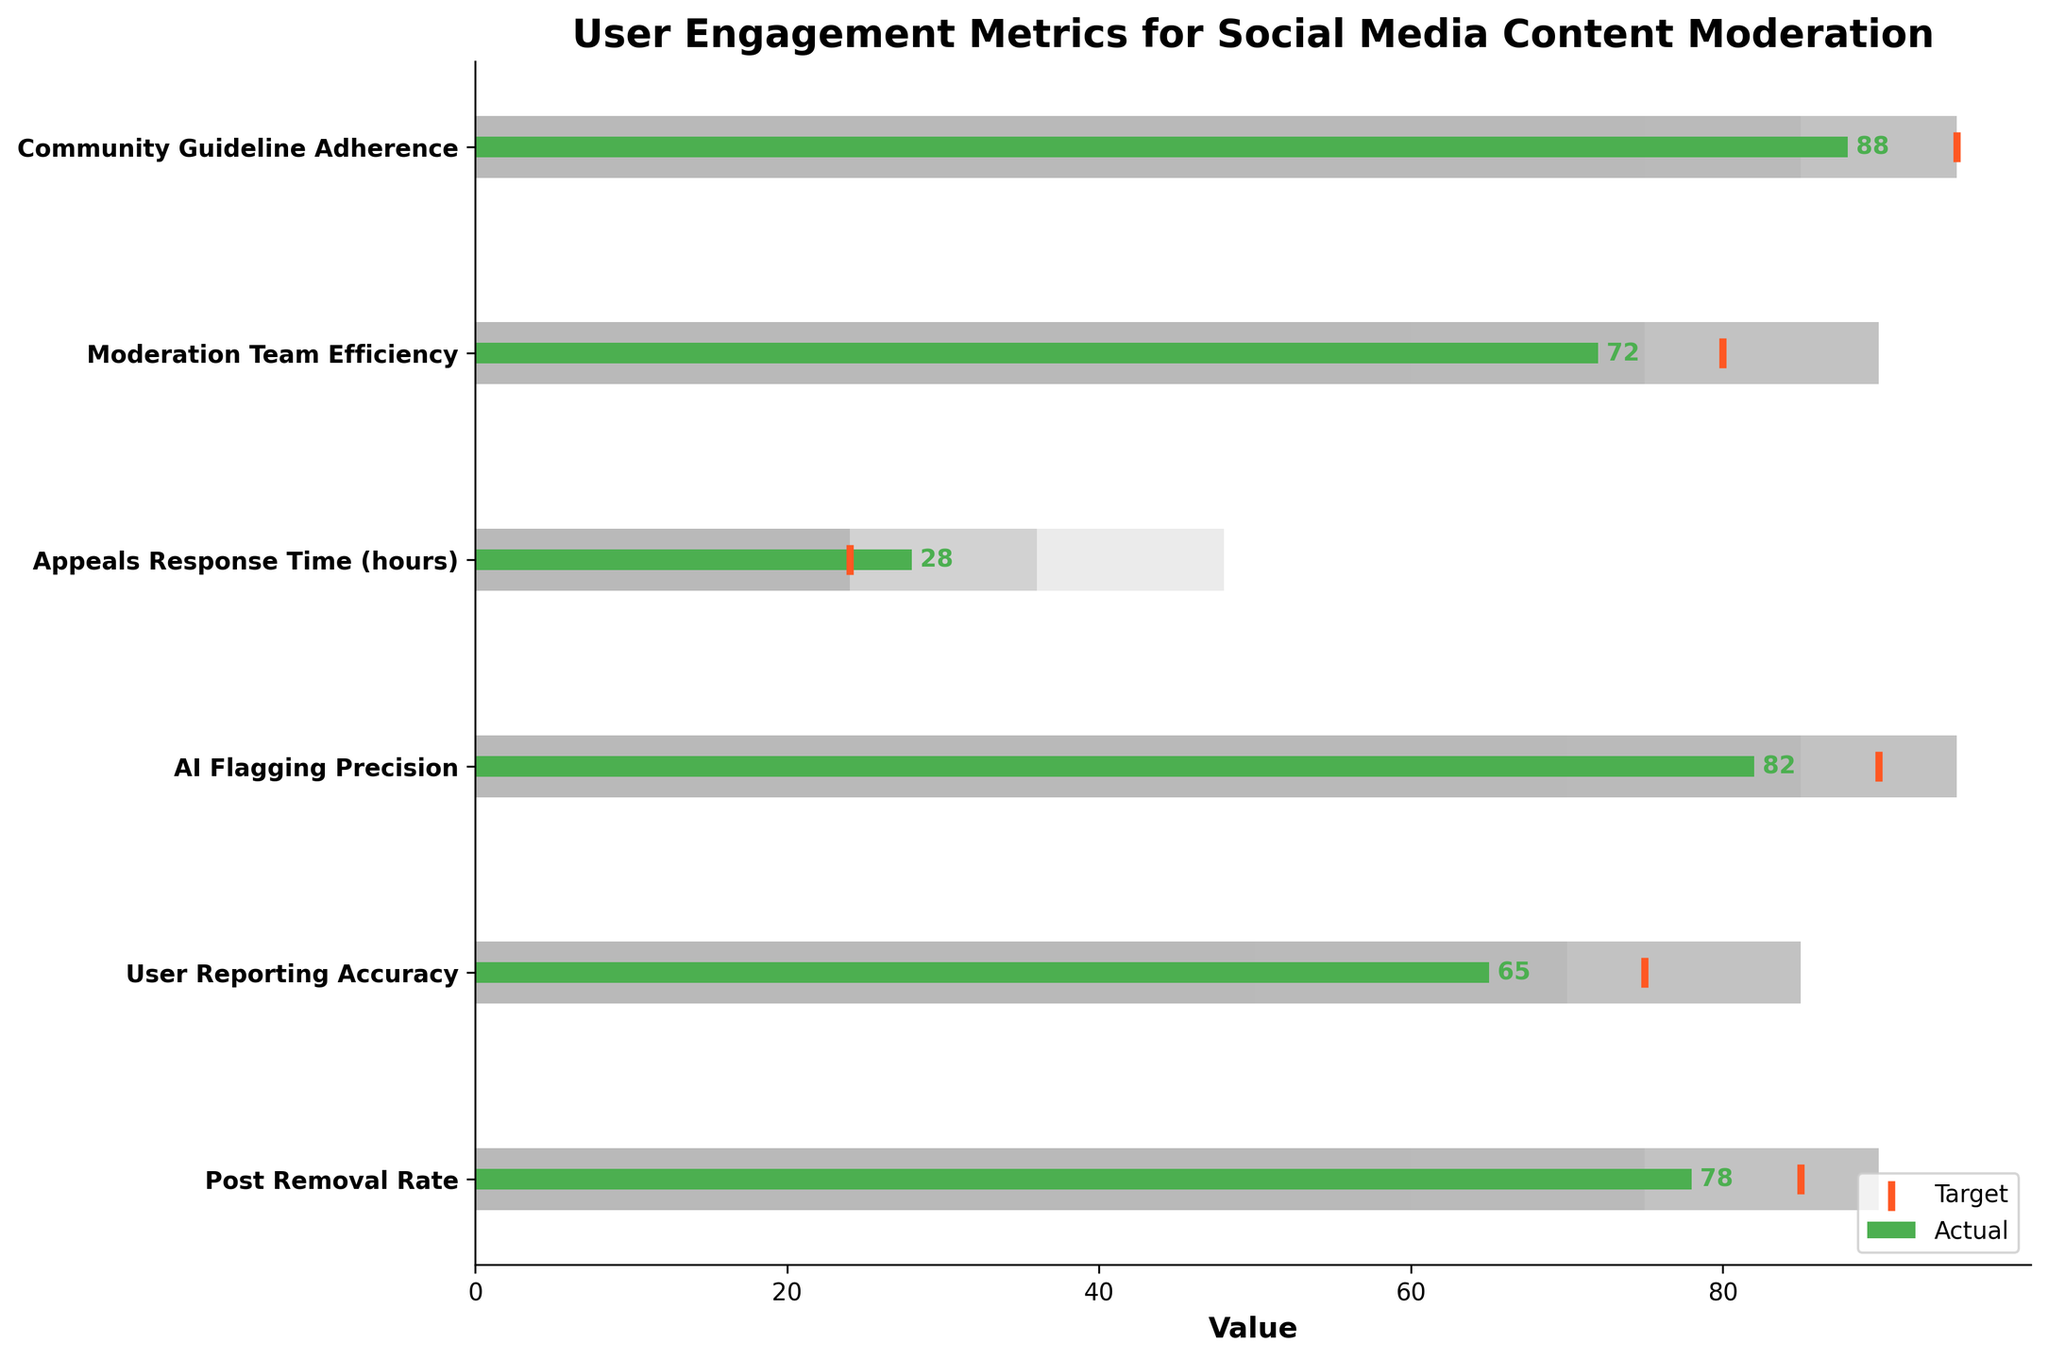What's the actual value for the "AI Flagging Precision" category? The actual values are represented by the green bars in the chart. For the "AI Flagging Precision" category, the green bar reaches up to 82.
Answer: 82 What is the target value for the "Post Removal Rate"? The target values are shown by the markers. For the "Post Removal Rate," the marker is located at 85.
Answer: 85 Which category has the highest actual value? By observing the length of the green bars, "Community Guideline Adherence" has the highest actual value of 88.
Answer: Community Guideline Adherence What is the difference between the actual and target values for "Moderation Team Efficiency"? The actual value for "Moderation Team Efficiency" is 72, and the target is 80. The difference is calculated as 80 - 72.
Answer: 8 Does "Appeals Response Time" meet its target value? The target value for "Appeals Response Time" is noted by the marker at 24. The actual value is represented by the green bar at 28, which is greater than 24, so it does not meet the target.
Answer: No What's the average actual value of all categories? Adding up all actual values: 78 + 65 + 82 + 28 + 72 + 88, we get 413. There are six categories, so the average is 413/6.
Answer: 68.83 